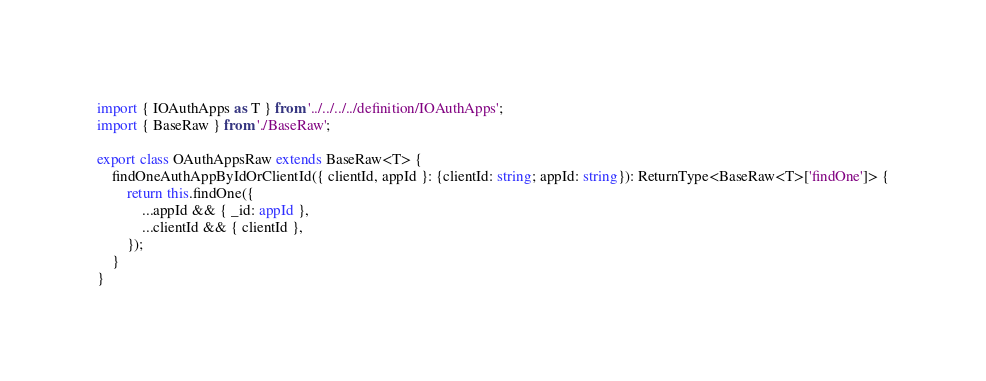<code> <loc_0><loc_0><loc_500><loc_500><_TypeScript_>import { IOAuthApps as T } from '../../../../definition/IOAuthApps';
import { BaseRaw } from './BaseRaw';

export class OAuthAppsRaw extends BaseRaw<T> {
	findOneAuthAppByIdOrClientId({ clientId, appId }: {clientId: string; appId: string}): ReturnType<BaseRaw<T>['findOne']> {
		return this.findOne({
			...appId && { _id: appId },
			...clientId && { clientId },
		});
	}
}
</code> 